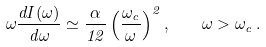<formula> <loc_0><loc_0><loc_500><loc_500>\omega \frac { d I ( \omega ) } { d \omega } \simeq \frac { \alpha } { 1 2 } \left ( \frac { \omega _ { c } } { \omega } \right ) ^ { 2 } , \quad \omega > \omega _ { c } \, .</formula> 